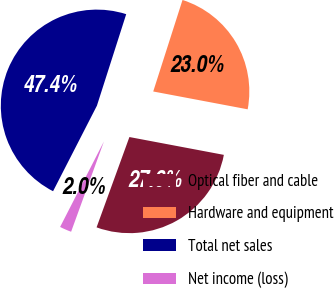<chart> <loc_0><loc_0><loc_500><loc_500><pie_chart><fcel>Optical fiber and cable<fcel>Hardware and equipment<fcel>Total net sales<fcel>Net income (loss)<nl><fcel>27.58%<fcel>23.04%<fcel>47.39%<fcel>1.99%<nl></chart> 